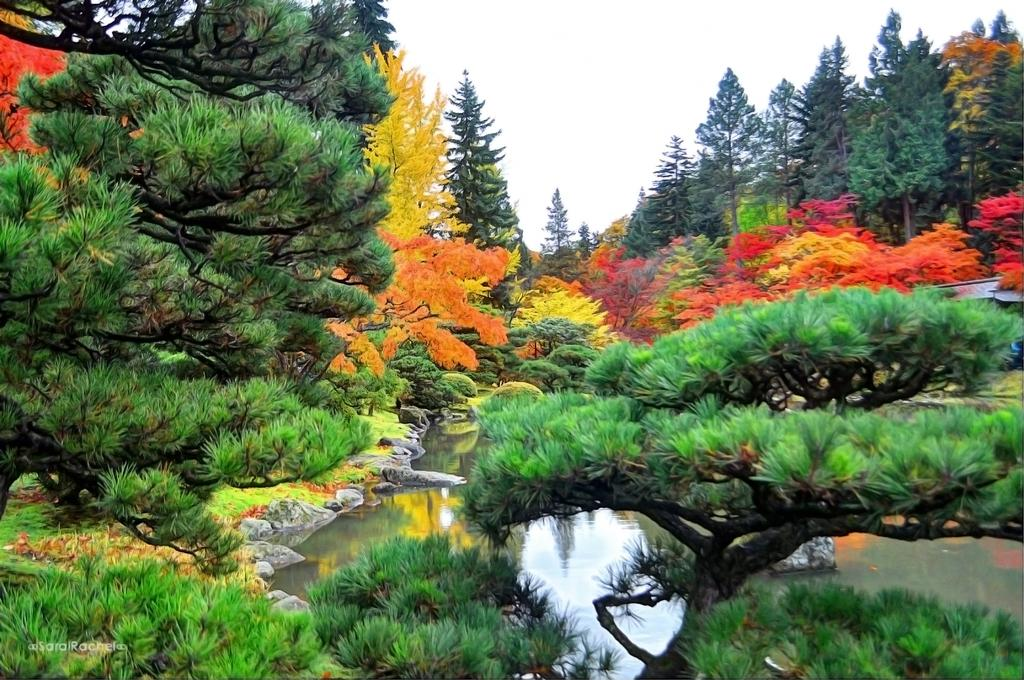What type of vegetation can be seen in the image? There are trees in the image. What natural element is visible in the image besides the trees? There is water visible in the image. What can be seen in the background of the image? The sky is visible in the background of the image. What type of truck can be seen driving through the water in the image? There is no truck present in the image; it only features trees, water, and the sky. 